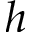Convert formula to latex. <formula><loc_0><loc_0><loc_500><loc_500>h</formula> 